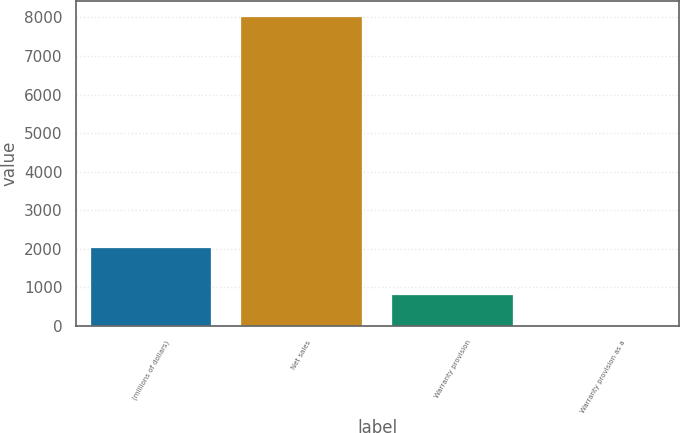Convert chart. <chart><loc_0><loc_0><loc_500><loc_500><bar_chart><fcel>(millions of dollars)<fcel>Net sales<fcel>Warranty provision<fcel>Warranty provision as a<nl><fcel>2015<fcel>8023.2<fcel>802.68<fcel>0.4<nl></chart> 